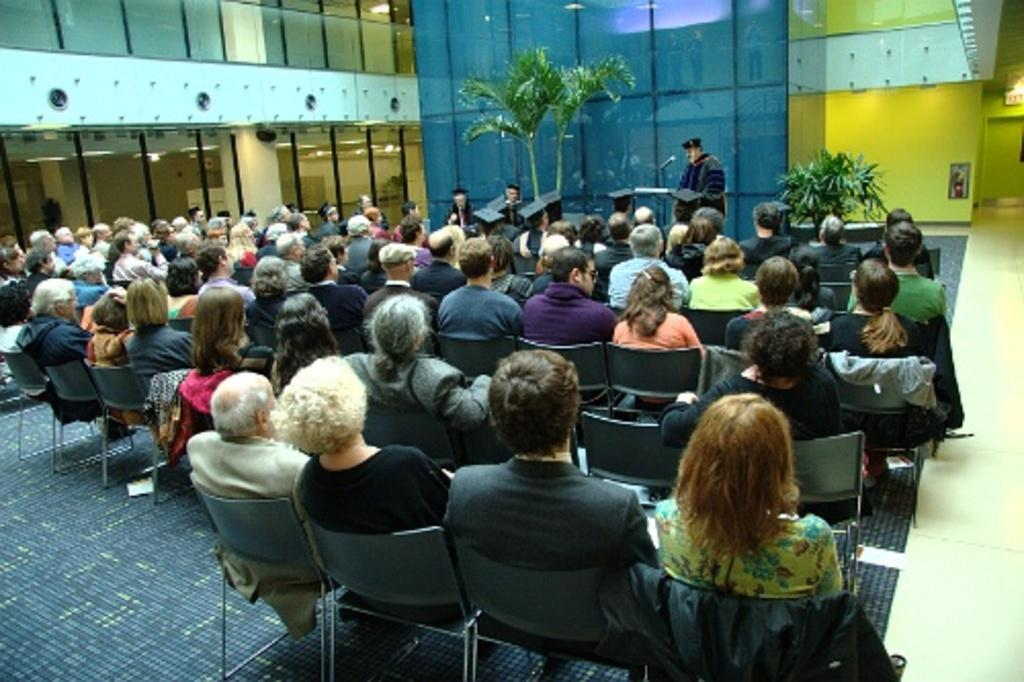How many people are in the image? There is a group of people in the image, but the exact number is not specified. What are the people doing in the image? The people are sitting on chairs in the image. What can be seen in the background of the image? Walls, a photo frame, trees, and plants are present in the background of the image. Reasoning: Let'g: Let's think step by step in order to produce the conversation. We start by identifying the main subject in the image, which is the group of people. Then, we describe what the people are doing, which is sitting on chairs. Next, we expand the conversation to include details about the background of the image, such as the walls, photo frame, trees, and plants. Each question is designed to elicit a specific detail about the image that is known from the provided facts. Absurd Question/Answer: How does the group of people stop the trees from growing in the image? There is no indication in the image that the group of people is stopping trees from growing, nor is there any interaction between the people and the trees. 